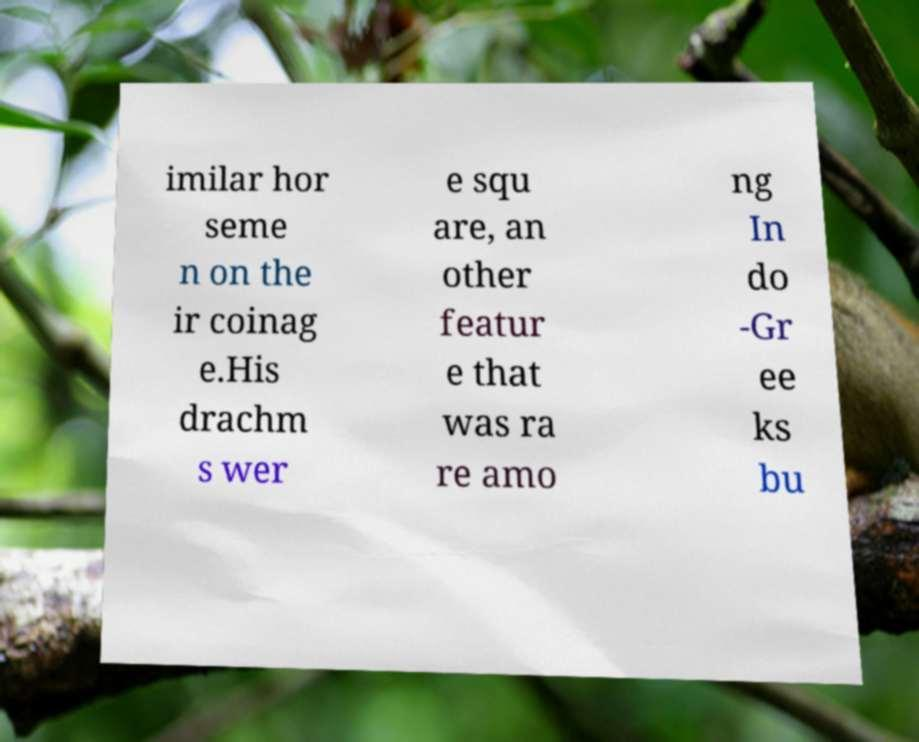What messages or text are displayed in this image? I need them in a readable, typed format. imilar hor seme n on the ir coinag e.His drachm s wer e squ are, an other featur e that was ra re amo ng In do -Gr ee ks bu 